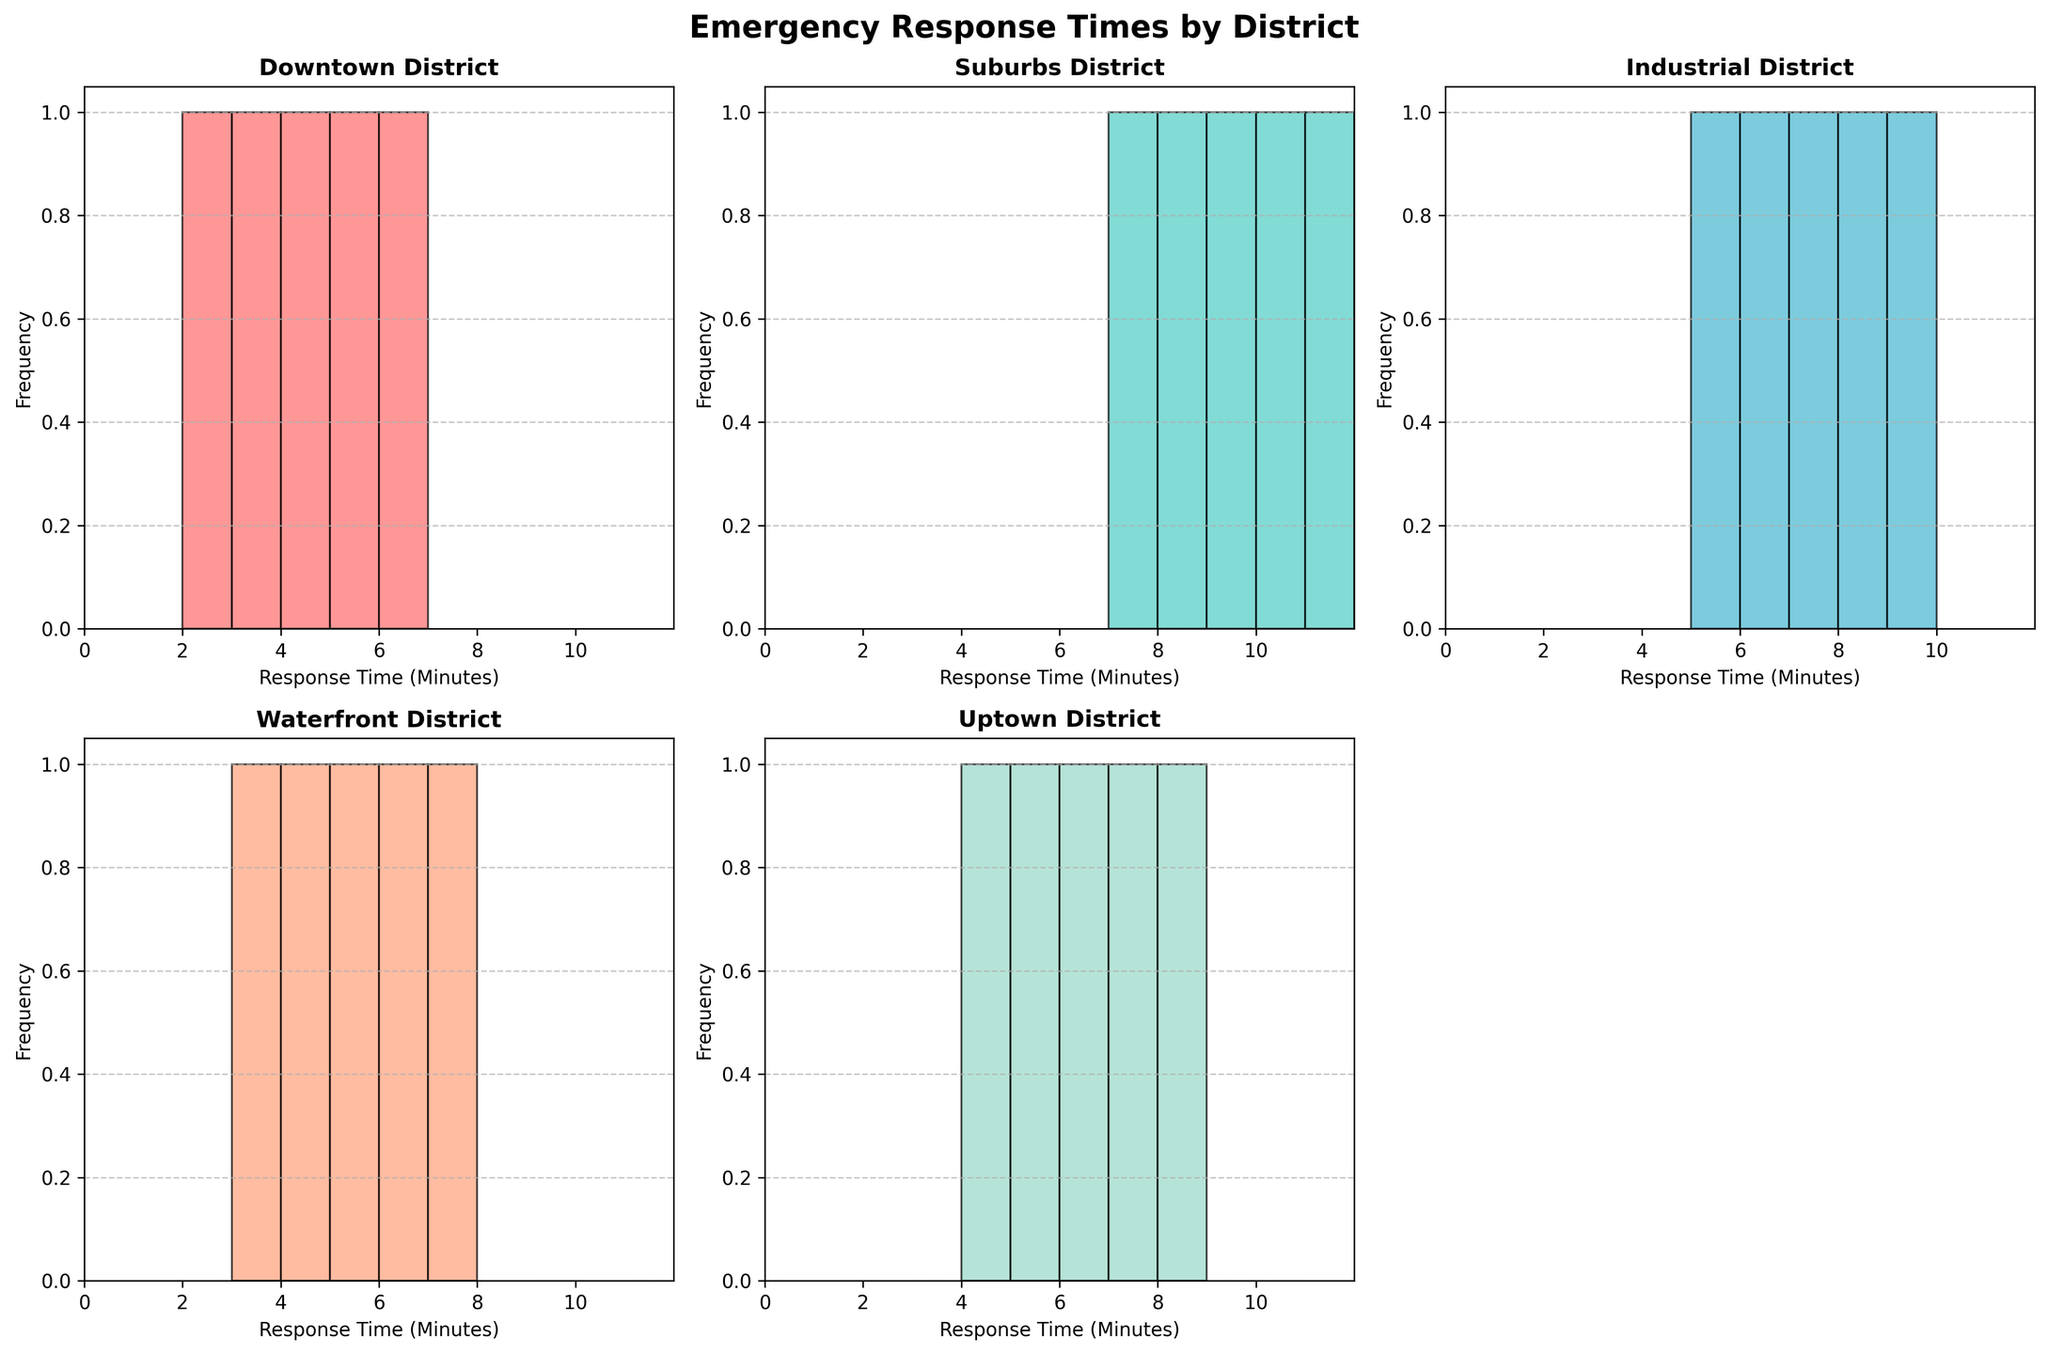Which district has the fastest emergency response time? By examining the histograms, find the district where the smallest response time bar appears at the far left side. Downtown has a bar starting at 2 minutes, which is the lowest response time among all districts.
Answer: Downtown Which district has the slowest emergency response time? By examining the histograms, find the district where the largest response time bar appears to the far right side. Suburbs has a bar extending to 11 minutes, which is the highest response time.
Answer: Suburbs What is the median response time for the Waterfront district? To find the median, list all response times for the Waterfront district (3, 4, 5, 6, 7) and determine the middle value. With 5 data points, the middle value (median) is the third value when sorted in numerical order.
Answer: 5 How many districts have their response times range between 2 and 6 minutes? Check each histogram to see where the response times fall within the range of 2 to 6 minutes. Downtown and Waterfront fall within this range. There are two such districts.
Answer: 2 Compare the average response times between the Industrial and Uptown districts. Which one is higher? Calculate the average response time by summing all response times and dividing by the number of points for Industrial (6 + 8 + 5 + 7 + 9)/5 = 7 and Uptown (5 + 7 + 6 + 4 + 8)/5 = 6. The average for Industrial is 7, which is higher.
Answer: Industrial Which district has the most uniform distribution of response times? Look at the histograms to identify where the bars are more evenly distributed across the response time range. The Waterfront district shows a more even distribution of response times from 3 to 7 minutes compared to other districts which have clusters or gaps.
Answer: Waterfront In the Suburbs district, what is the most frequent response time range? Check the histogram for Suburbs and find the bar with the highest frequency. The bar for 8-9 minutes shows the highest frequency occurring twice.
Answer: 8-9 minutes Are there any districts where the response times do not exceed 7 minutes? By examining each histogram, identify the districts where all the bars fall within 7 minutes or less. Downtown and Waterfront districts both meet this criterion.
Answer: Downtown and Waterfront What’s the range of response times in Uptown district? Range is calculated by subtracting the smallest value from the largest value. For Uptown, the smallest time is 4 and the largest is 8 minutes. Therefore, 8 - 4 = 4 minutes.
Answer: 4 minutes 